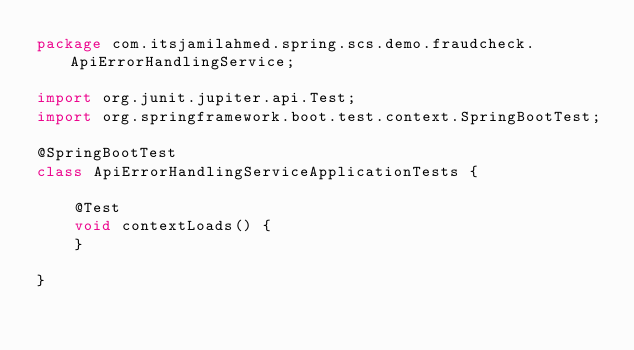Convert code to text. <code><loc_0><loc_0><loc_500><loc_500><_Java_>package com.itsjamilahmed.spring.scs.demo.fraudcheck.ApiErrorHandlingService;

import org.junit.jupiter.api.Test;
import org.springframework.boot.test.context.SpringBootTest;

@SpringBootTest
class ApiErrorHandlingServiceApplicationTests {

	@Test
	void contextLoads() {
	}

}
</code> 